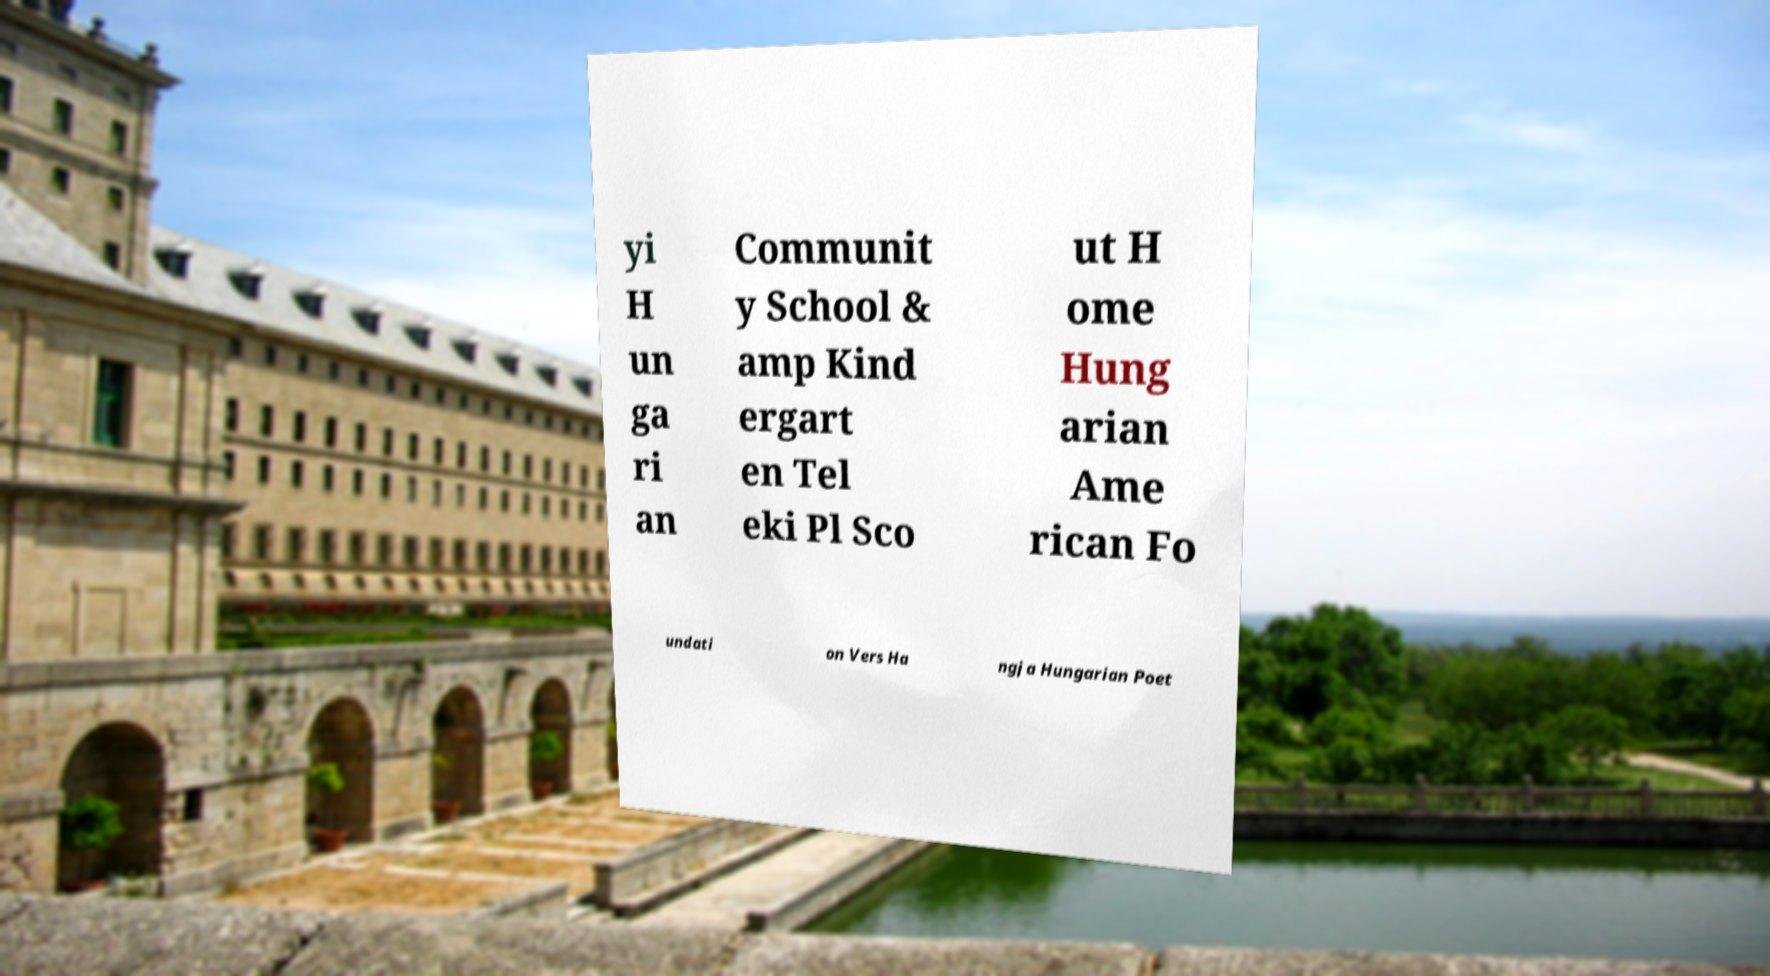Can you read and provide the text displayed in the image?This photo seems to have some interesting text. Can you extract and type it out for me? yi H un ga ri an Communit y School & amp Kind ergart en Tel eki Pl Sco ut H ome Hung arian Ame rican Fo undati on Vers Ha ngja Hungarian Poet 